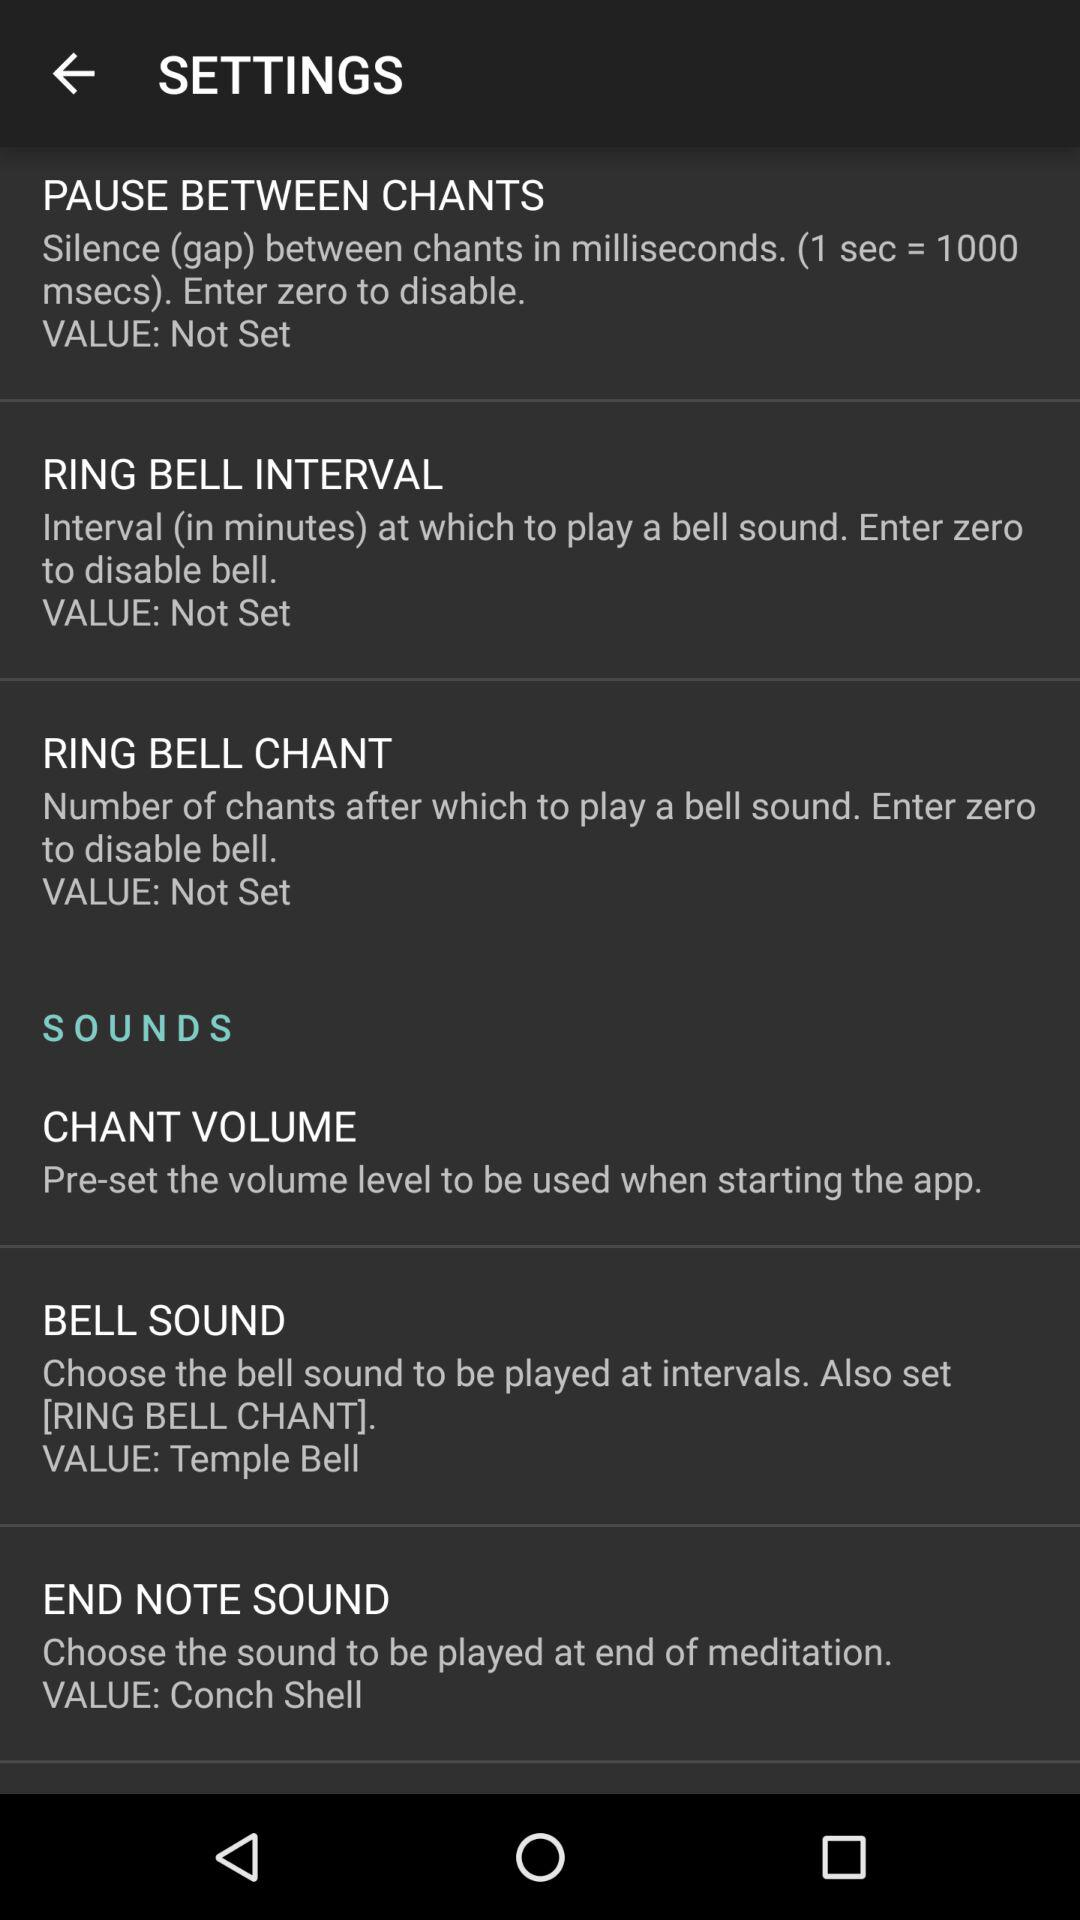How many settings do not have a value set?
Answer the question using a single word or phrase. 3 